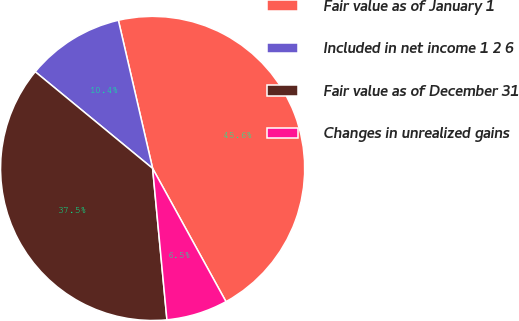Convert chart to OTSL. <chart><loc_0><loc_0><loc_500><loc_500><pie_chart><fcel>Fair value as of January 1<fcel>Included in net income 1 2 6<fcel>Fair value as of December 31<fcel>Changes in unrealized gains<nl><fcel>45.6%<fcel>10.42%<fcel>37.46%<fcel>6.51%<nl></chart> 